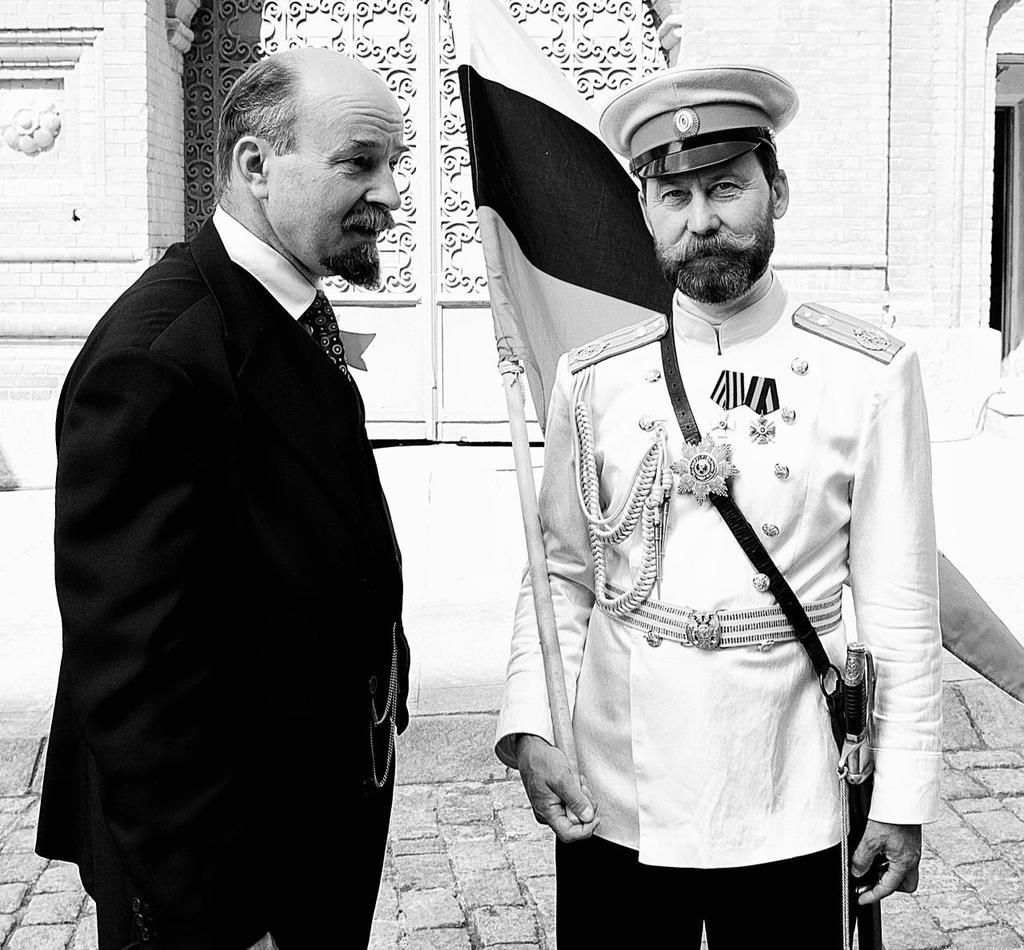How many people are in the image? There are two persons standing in the image. What is one person holding in the image? One person is holding a flag. What can be seen in the background of the image? There are walls of a building visible in the background of the image. What type of gold jewelry is the person wearing in the image? There is no gold jewelry visible on either person in the image. What type of jeans is the person wearing in the image? There is no mention of jeans in the image; both persons are fully clothed, but the specific type of clothing is not specified. 